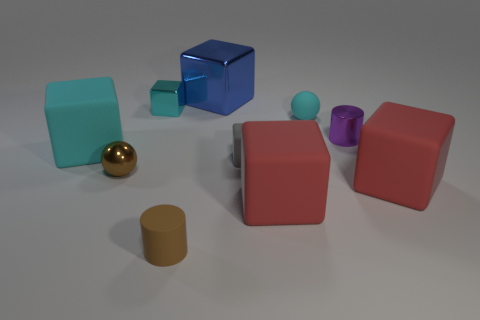Does the matte cylinder have the same color as the small metallic sphere?
Keep it short and to the point. Yes. There is a tiny matte thing behind the purple metal cylinder; is there a large cyan cube that is right of it?
Your answer should be compact. No. How many cylinders are in front of the matte cube that is to the right of the small ball that is behind the small purple cylinder?
Your answer should be compact. 1. Is the number of cyan matte blocks less than the number of tiny brown things?
Give a very brief answer. Yes. There is a large object behind the large cyan matte thing; is its shape the same as the cyan rubber thing that is to the left of the brown sphere?
Offer a very short reply. Yes. What is the color of the shiny sphere?
Offer a very short reply. Brown. What number of rubber things are either tiny objects or gray blocks?
Give a very brief answer. 3. What color is the other object that is the same shape as the tiny cyan matte object?
Provide a short and direct response. Brown. Is there a yellow cylinder?
Give a very brief answer. No. Does the cylinder that is behind the small gray cube have the same material as the tiny block that is on the right side of the blue object?
Offer a terse response. No. 